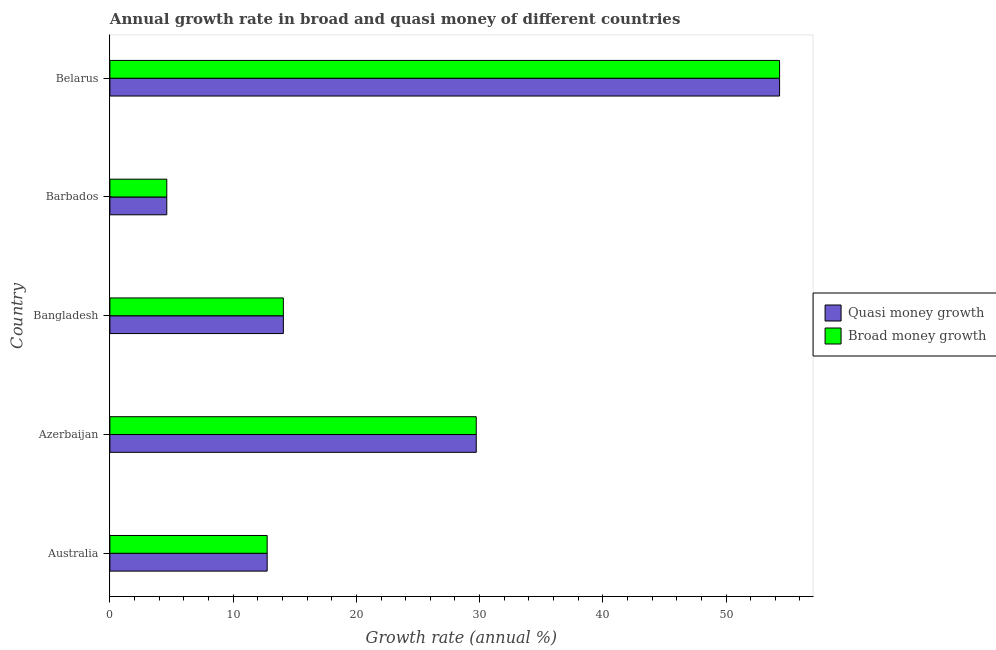How many groups of bars are there?
Your answer should be very brief. 5. Are the number of bars per tick equal to the number of legend labels?
Offer a terse response. Yes. Are the number of bars on each tick of the Y-axis equal?
Provide a succinct answer. Yes. How many bars are there on the 1st tick from the top?
Your response must be concise. 2. What is the label of the 2nd group of bars from the top?
Make the answer very short. Barbados. What is the annual growth rate in broad money in Belarus?
Make the answer very short. 54.35. Across all countries, what is the maximum annual growth rate in quasi money?
Provide a short and direct response. 54.35. Across all countries, what is the minimum annual growth rate in broad money?
Give a very brief answer. 4.62. In which country was the annual growth rate in broad money maximum?
Your answer should be compact. Belarus. In which country was the annual growth rate in quasi money minimum?
Ensure brevity in your answer.  Barbados. What is the total annual growth rate in quasi money in the graph?
Provide a short and direct response. 115.53. What is the difference between the annual growth rate in broad money in Azerbaijan and that in Bangladesh?
Offer a very short reply. 15.65. What is the difference between the annual growth rate in quasi money in Bangladesh and the annual growth rate in broad money in Belarus?
Your answer should be compact. -40.27. What is the average annual growth rate in broad money per country?
Offer a terse response. 23.11. What is the difference between the annual growth rate in quasi money and annual growth rate in broad money in Bangladesh?
Ensure brevity in your answer.  0. What is the ratio of the annual growth rate in broad money in Australia to that in Bangladesh?
Provide a succinct answer. 0.91. What is the difference between the highest and the second highest annual growth rate in broad money?
Offer a very short reply. 24.61. What is the difference between the highest and the lowest annual growth rate in broad money?
Make the answer very short. 49.73. In how many countries, is the annual growth rate in broad money greater than the average annual growth rate in broad money taken over all countries?
Give a very brief answer. 2. Is the sum of the annual growth rate in quasi money in Australia and Azerbaijan greater than the maximum annual growth rate in broad money across all countries?
Offer a very short reply. No. What does the 2nd bar from the top in Australia represents?
Your answer should be very brief. Quasi money growth. What does the 1st bar from the bottom in Barbados represents?
Provide a short and direct response. Quasi money growth. Are the values on the major ticks of X-axis written in scientific E-notation?
Ensure brevity in your answer.  No. Does the graph contain grids?
Make the answer very short. No. Where does the legend appear in the graph?
Your answer should be compact. Center right. How are the legend labels stacked?
Give a very brief answer. Vertical. What is the title of the graph?
Offer a very short reply. Annual growth rate in broad and quasi money of different countries. What is the label or title of the X-axis?
Your response must be concise. Growth rate (annual %). What is the label or title of the Y-axis?
Offer a terse response. Country. What is the Growth rate (annual %) in Quasi money growth in Australia?
Ensure brevity in your answer.  12.76. What is the Growth rate (annual %) of Broad money growth in Australia?
Your answer should be compact. 12.76. What is the Growth rate (annual %) in Quasi money growth in Azerbaijan?
Provide a short and direct response. 29.73. What is the Growth rate (annual %) in Broad money growth in Azerbaijan?
Your answer should be compact. 29.73. What is the Growth rate (annual %) of Quasi money growth in Bangladesh?
Ensure brevity in your answer.  14.08. What is the Growth rate (annual %) of Broad money growth in Bangladesh?
Offer a terse response. 14.08. What is the Growth rate (annual %) of Quasi money growth in Barbados?
Your answer should be compact. 4.62. What is the Growth rate (annual %) in Broad money growth in Barbados?
Provide a succinct answer. 4.62. What is the Growth rate (annual %) of Quasi money growth in Belarus?
Your answer should be very brief. 54.35. What is the Growth rate (annual %) of Broad money growth in Belarus?
Give a very brief answer. 54.35. Across all countries, what is the maximum Growth rate (annual %) in Quasi money growth?
Keep it short and to the point. 54.35. Across all countries, what is the maximum Growth rate (annual %) of Broad money growth?
Provide a succinct answer. 54.35. Across all countries, what is the minimum Growth rate (annual %) in Quasi money growth?
Provide a succinct answer. 4.62. Across all countries, what is the minimum Growth rate (annual %) of Broad money growth?
Ensure brevity in your answer.  4.62. What is the total Growth rate (annual %) of Quasi money growth in the graph?
Your answer should be compact. 115.53. What is the total Growth rate (annual %) of Broad money growth in the graph?
Ensure brevity in your answer.  115.53. What is the difference between the Growth rate (annual %) of Quasi money growth in Australia and that in Azerbaijan?
Offer a terse response. -16.97. What is the difference between the Growth rate (annual %) of Broad money growth in Australia and that in Azerbaijan?
Provide a succinct answer. -16.97. What is the difference between the Growth rate (annual %) of Quasi money growth in Australia and that in Bangladesh?
Offer a very short reply. -1.31. What is the difference between the Growth rate (annual %) of Broad money growth in Australia and that in Bangladesh?
Ensure brevity in your answer.  -1.31. What is the difference between the Growth rate (annual %) of Quasi money growth in Australia and that in Barbados?
Provide a succinct answer. 8.15. What is the difference between the Growth rate (annual %) in Broad money growth in Australia and that in Barbados?
Keep it short and to the point. 8.15. What is the difference between the Growth rate (annual %) of Quasi money growth in Australia and that in Belarus?
Your answer should be very brief. -41.58. What is the difference between the Growth rate (annual %) of Broad money growth in Australia and that in Belarus?
Make the answer very short. -41.58. What is the difference between the Growth rate (annual %) in Quasi money growth in Azerbaijan and that in Bangladesh?
Your response must be concise. 15.65. What is the difference between the Growth rate (annual %) of Broad money growth in Azerbaijan and that in Bangladesh?
Offer a terse response. 15.65. What is the difference between the Growth rate (annual %) in Quasi money growth in Azerbaijan and that in Barbados?
Your answer should be compact. 25.11. What is the difference between the Growth rate (annual %) in Broad money growth in Azerbaijan and that in Barbados?
Your answer should be compact. 25.11. What is the difference between the Growth rate (annual %) of Quasi money growth in Azerbaijan and that in Belarus?
Your answer should be very brief. -24.61. What is the difference between the Growth rate (annual %) of Broad money growth in Azerbaijan and that in Belarus?
Your response must be concise. -24.61. What is the difference between the Growth rate (annual %) of Quasi money growth in Bangladesh and that in Barbados?
Your response must be concise. 9.46. What is the difference between the Growth rate (annual %) of Broad money growth in Bangladesh and that in Barbados?
Make the answer very short. 9.46. What is the difference between the Growth rate (annual %) in Quasi money growth in Bangladesh and that in Belarus?
Provide a succinct answer. -40.27. What is the difference between the Growth rate (annual %) of Broad money growth in Bangladesh and that in Belarus?
Keep it short and to the point. -40.27. What is the difference between the Growth rate (annual %) of Quasi money growth in Barbados and that in Belarus?
Provide a succinct answer. -49.73. What is the difference between the Growth rate (annual %) of Broad money growth in Barbados and that in Belarus?
Your answer should be very brief. -49.73. What is the difference between the Growth rate (annual %) in Quasi money growth in Australia and the Growth rate (annual %) in Broad money growth in Azerbaijan?
Your response must be concise. -16.97. What is the difference between the Growth rate (annual %) in Quasi money growth in Australia and the Growth rate (annual %) in Broad money growth in Bangladesh?
Make the answer very short. -1.31. What is the difference between the Growth rate (annual %) of Quasi money growth in Australia and the Growth rate (annual %) of Broad money growth in Barbados?
Give a very brief answer. 8.15. What is the difference between the Growth rate (annual %) in Quasi money growth in Australia and the Growth rate (annual %) in Broad money growth in Belarus?
Offer a very short reply. -41.58. What is the difference between the Growth rate (annual %) of Quasi money growth in Azerbaijan and the Growth rate (annual %) of Broad money growth in Bangladesh?
Provide a short and direct response. 15.65. What is the difference between the Growth rate (annual %) in Quasi money growth in Azerbaijan and the Growth rate (annual %) in Broad money growth in Barbados?
Make the answer very short. 25.11. What is the difference between the Growth rate (annual %) in Quasi money growth in Azerbaijan and the Growth rate (annual %) in Broad money growth in Belarus?
Your response must be concise. -24.61. What is the difference between the Growth rate (annual %) in Quasi money growth in Bangladesh and the Growth rate (annual %) in Broad money growth in Barbados?
Provide a succinct answer. 9.46. What is the difference between the Growth rate (annual %) in Quasi money growth in Bangladesh and the Growth rate (annual %) in Broad money growth in Belarus?
Provide a succinct answer. -40.27. What is the difference between the Growth rate (annual %) in Quasi money growth in Barbados and the Growth rate (annual %) in Broad money growth in Belarus?
Your response must be concise. -49.73. What is the average Growth rate (annual %) in Quasi money growth per country?
Your response must be concise. 23.11. What is the average Growth rate (annual %) of Broad money growth per country?
Your response must be concise. 23.11. What is the difference between the Growth rate (annual %) of Quasi money growth and Growth rate (annual %) of Broad money growth in Australia?
Provide a short and direct response. 0. What is the difference between the Growth rate (annual %) in Quasi money growth and Growth rate (annual %) in Broad money growth in Bangladesh?
Ensure brevity in your answer.  0. What is the difference between the Growth rate (annual %) of Quasi money growth and Growth rate (annual %) of Broad money growth in Barbados?
Offer a very short reply. 0. What is the difference between the Growth rate (annual %) of Quasi money growth and Growth rate (annual %) of Broad money growth in Belarus?
Ensure brevity in your answer.  0. What is the ratio of the Growth rate (annual %) in Quasi money growth in Australia to that in Azerbaijan?
Provide a short and direct response. 0.43. What is the ratio of the Growth rate (annual %) of Broad money growth in Australia to that in Azerbaijan?
Offer a very short reply. 0.43. What is the ratio of the Growth rate (annual %) in Quasi money growth in Australia to that in Bangladesh?
Offer a terse response. 0.91. What is the ratio of the Growth rate (annual %) of Broad money growth in Australia to that in Bangladesh?
Make the answer very short. 0.91. What is the ratio of the Growth rate (annual %) of Quasi money growth in Australia to that in Barbados?
Keep it short and to the point. 2.76. What is the ratio of the Growth rate (annual %) in Broad money growth in Australia to that in Barbados?
Your answer should be very brief. 2.76. What is the ratio of the Growth rate (annual %) of Quasi money growth in Australia to that in Belarus?
Ensure brevity in your answer.  0.23. What is the ratio of the Growth rate (annual %) of Broad money growth in Australia to that in Belarus?
Offer a terse response. 0.23. What is the ratio of the Growth rate (annual %) of Quasi money growth in Azerbaijan to that in Bangladesh?
Provide a short and direct response. 2.11. What is the ratio of the Growth rate (annual %) of Broad money growth in Azerbaijan to that in Bangladesh?
Ensure brevity in your answer.  2.11. What is the ratio of the Growth rate (annual %) of Quasi money growth in Azerbaijan to that in Barbados?
Your answer should be compact. 6.44. What is the ratio of the Growth rate (annual %) in Broad money growth in Azerbaijan to that in Barbados?
Offer a very short reply. 6.44. What is the ratio of the Growth rate (annual %) in Quasi money growth in Azerbaijan to that in Belarus?
Offer a terse response. 0.55. What is the ratio of the Growth rate (annual %) of Broad money growth in Azerbaijan to that in Belarus?
Provide a short and direct response. 0.55. What is the ratio of the Growth rate (annual %) of Quasi money growth in Bangladesh to that in Barbados?
Ensure brevity in your answer.  3.05. What is the ratio of the Growth rate (annual %) in Broad money growth in Bangladesh to that in Barbados?
Offer a very short reply. 3.05. What is the ratio of the Growth rate (annual %) in Quasi money growth in Bangladesh to that in Belarus?
Provide a short and direct response. 0.26. What is the ratio of the Growth rate (annual %) in Broad money growth in Bangladesh to that in Belarus?
Make the answer very short. 0.26. What is the ratio of the Growth rate (annual %) in Quasi money growth in Barbados to that in Belarus?
Make the answer very short. 0.09. What is the ratio of the Growth rate (annual %) of Broad money growth in Barbados to that in Belarus?
Provide a succinct answer. 0.09. What is the difference between the highest and the second highest Growth rate (annual %) of Quasi money growth?
Your response must be concise. 24.61. What is the difference between the highest and the second highest Growth rate (annual %) of Broad money growth?
Your response must be concise. 24.61. What is the difference between the highest and the lowest Growth rate (annual %) of Quasi money growth?
Provide a succinct answer. 49.73. What is the difference between the highest and the lowest Growth rate (annual %) in Broad money growth?
Make the answer very short. 49.73. 